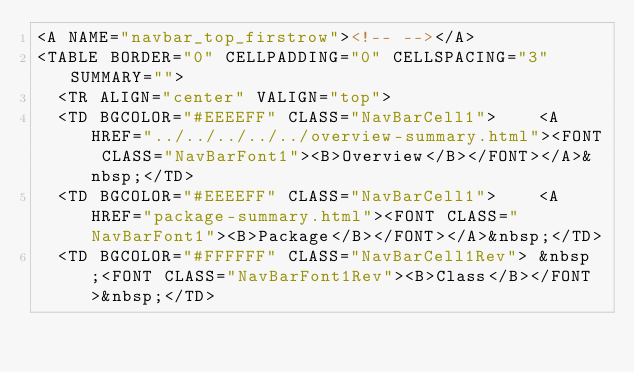Convert code to text. <code><loc_0><loc_0><loc_500><loc_500><_HTML_><A NAME="navbar_top_firstrow"><!-- --></A>
<TABLE BORDER="0" CELLPADDING="0" CELLSPACING="3" SUMMARY="">
  <TR ALIGN="center" VALIGN="top">
  <TD BGCOLOR="#EEEEFF" CLASS="NavBarCell1">    <A HREF="../../../../../overview-summary.html"><FONT CLASS="NavBarFont1"><B>Overview</B></FONT></A>&nbsp;</TD>
  <TD BGCOLOR="#EEEEFF" CLASS="NavBarCell1">    <A HREF="package-summary.html"><FONT CLASS="NavBarFont1"><B>Package</B></FONT></A>&nbsp;</TD>
  <TD BGCOLOR="#FFFFFF" CLASS="NavBarCell1Rev"> &nbsp;<FONT CLASS="NavBarFont1Rev"><B>Class</B></FONT>&nbsp;</TD></code> 